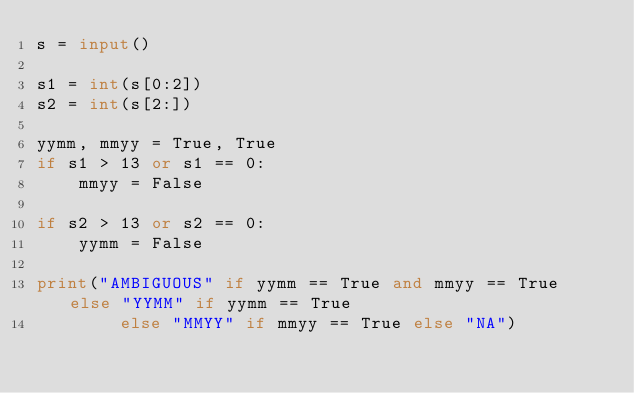Convert code to text. <code><loc_0><loc_0><loc_500><loc_500><_Python_>s = input()

s1 = int(s[0:2])
s2 = int(s[2:])

yymm, mmyy = True, True
if s1 > 13 or s1 == 0:
    mmyy = False

if s2 > 13 or s2 == 0:
    yymm = False

print("AMBIGUOUS" if yymm == True and mmyy == True else "YYMM" if yymm == True
        else "MMYY" if mmyy == True else "NA")
</code> 